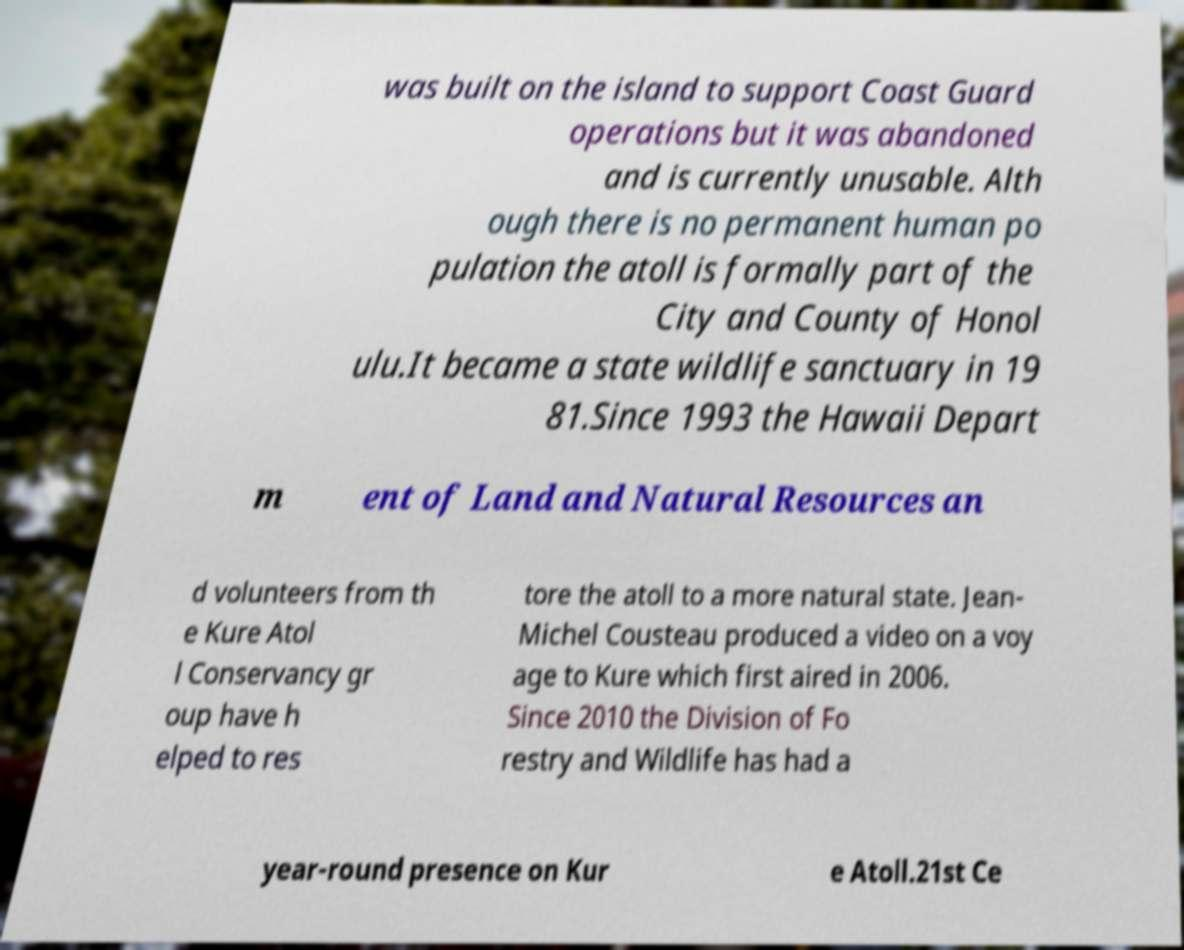Can you accurately transcribe the text from the provided image for me? was built on the island to support Coast Guard operations but it was abandoned and is currently unusable. Alth ough there is no permanent human po pulation the atoll is formally part of the City and County of Honol ulu.It became a state wildlife sanctuary in 19 81.Since 1993 the Hawaii Depart m ent of Land and Natural Resources an d volunteers from th e Kure Atol l Conservancy gr oup have h elped to res tore the atoll to a more natural state. Jean- Michel Cousteau produced a video on a voy age to Kure which first aired in 2006. Since 2010 the Division of Fo restry and Wildlife has had a year-round presence on Kur e Atoll.21st Ce 